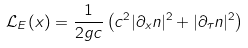<formula> <loc_0><loc_0><loc_500><loc_500>\mathcal { L } _ { E } ( x ) = \frac { 1 } { 2 g c } \left ( c ^ { 2 } | \partial _ { x } n | ^ { 2 } + | \partial _ { \tau } n | ^ { 2 } \right )</formula> 